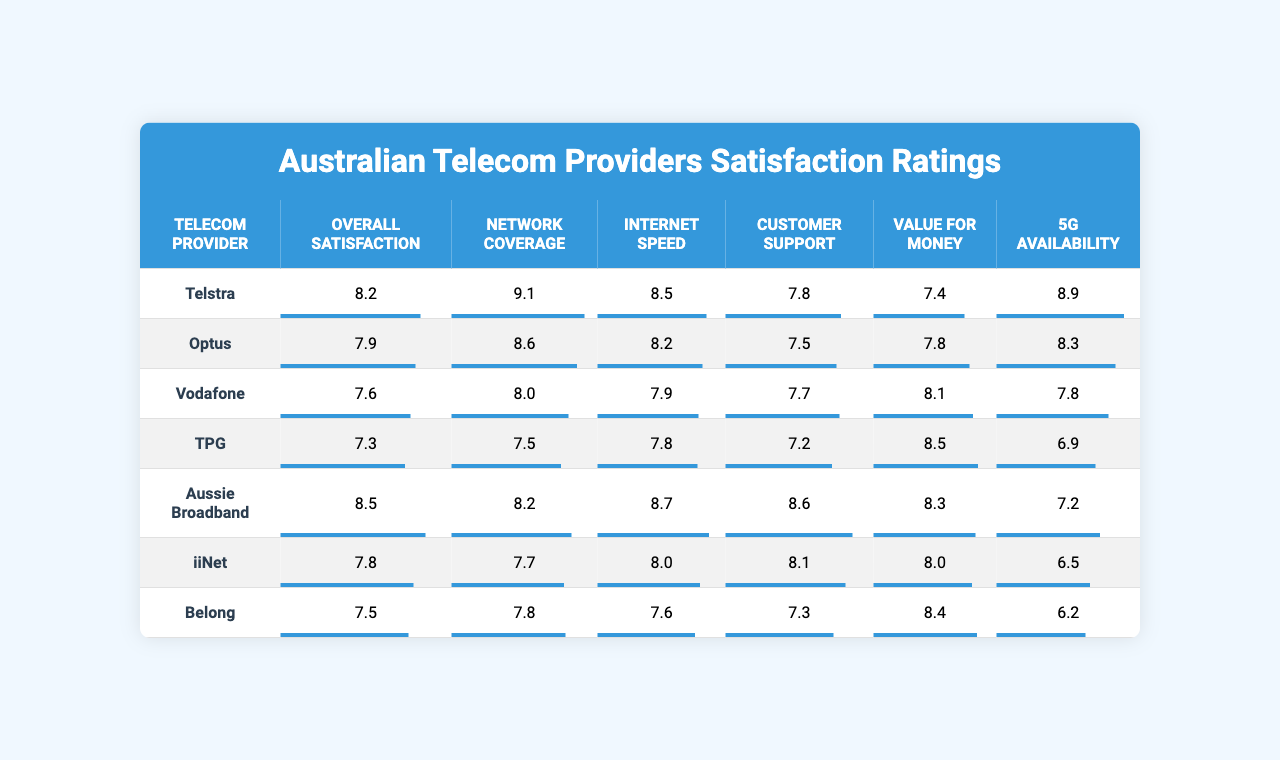What is Telstra's overall satisfaction rating? The table shows that Telstra's overall satisfaction rating is listed under the "Overall Satisfaction" column. According to the data, this value is 8.2.
Answer: 8.2 Which telecom provider has the highest rating for Network Coverage? By looking at the "Network Coverage" column, Telstra has the highest rating at 9.1 compared to other providers.
Answer: Telstra What is the average Customer Support rating across all providers? To calculate the average, sum the Customer Support ratings: (7.8 + 7.5 + 7.7 + 7.2 + 8.6 + 8.1 + 7.3) = 55.2. There are 7 providers, so the average is 55.2 / 7 = 7.87.
Answer: 7.87 Is Vodafone's Internet Speed rating lower than TPG's? Vodafone's rating for Internet Speed is 7.9, while TPG's is 7.8. Since 7.9 is greater than 7.8, the statement is false.
Answer: No Which provider offers the best Value for Money rating? In the "Value for Money" column, TPG has the highest rating at 8.5, meaning it offers the best value compared to the others.
Answer: TPG What is the difference in Overall Satisfaction between Aussie Broadband and iiNet? Aussie Broadband has an Overall Satisfaction rating of 8.5, while iiNet has a rating of 7.8. The difference is 8.5 - 7.8 = 0.7.
Answer: 0.7 Which provider has the lowest 5G Availability score? The "5G Availability" column shows that TPG has the lowest score at 6.9 when compared to other telecom providers.
Answer: TPG Are customer satisfaction ratings for Optus higher than for Belong in every service category? By comparing each corresponding category between Optus and Belong, despite Optus rating higher in most categories, it does not have a higher rating in Customer Support (7.5 vs. 7.3). Hence, this statement is not true for all categories.
Answer: No What is the overall average satisfaction rating of all telecom providers listed? To find the overall average, sum all the Overall Satisfaction ratings: (8.2 + 7.9 + 7.6 + 7.3 + 8.5 + 7.8 + 7.5) = 56.8. There are 7 providers, so the overall average is 56.8 / 7 = 8.11.
Answer: 8.11 Which provider has a lower rating in Internet Speed than their rating in Network Coverage? By checking the ratings, TPG has a Network Coverage of 7.5 and an Internet Speed of 7.8, indicating its Internet Speed rating is higher. The same pattern is observed for Belong (7.8 vs. 7.6). Thus, the answer is Belong.
Answer: Belong 